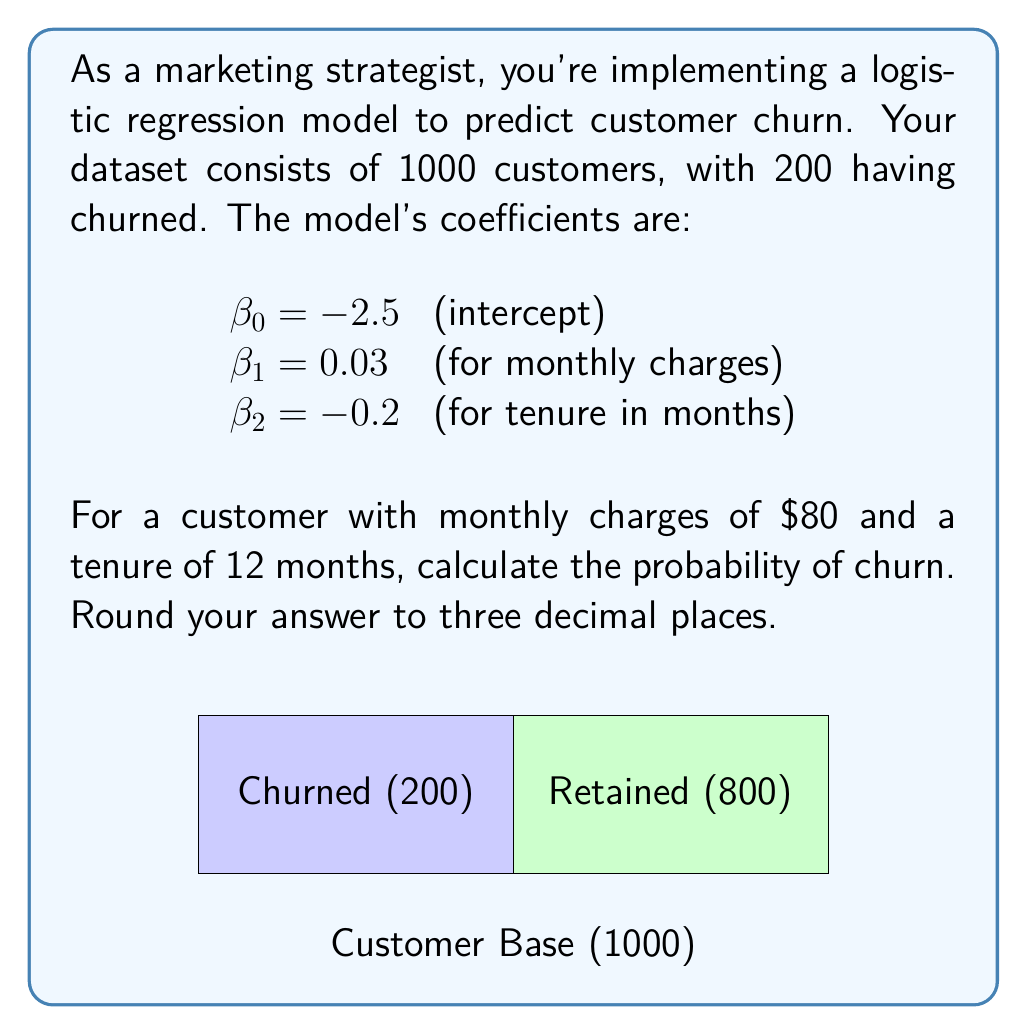Can you answer this question? Let's approach this step-by-step:

1) The logistic regression model uses the logistic function:

   $$P(churn) = \frac{1}{1 + e^{-z}}$$

   where $z = \beta_0 + \beta_1x_1 + \beta_2x_2 + ... + \beta_nx_n$

2) In our case:
   $z = \beta_0 + \beta_1(\text{monthly charges}) + \beta_2(\text{tenure})$

3) Substituting the values:
   $z = -2.5 + 0.03(80) + (-0.2)(12)$

4) Let's calculate $z$:
   $z = -2.5 + 2.4 - 2.4 = -2.5$

5) Now, we can calculate the probability:

   $$P(churn) = \frac{1}{1 + e^{-(-2.5)}} = \frac{1}{1 + e^{2.5}}$$

6) Using a calculator (or programming function):

   $$P(churn) = \frac{1}{1 + 12.1825} = 0.0758$$

7) Rounding to three decimal places: 0.076

This means there's a 7.6% chance of this customer churning.
Answer: 0.076 